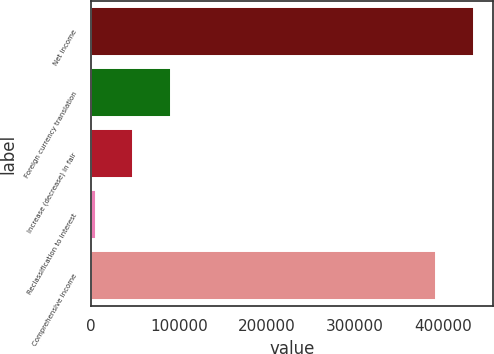Convert chart. <chart><loc_0><loc_0><loc_500><loc_500><bar_chart><fcel>Net income<fcel>Foreign currency translation<fcel>Increase (decrease) in fair<fcel>Reclassification to interest<fcel>Comprehensive income<nl><fcel>434885<fcel>90344.8<fcel>47656.4<fcel>4968<fcel>392197<nl></chart> 